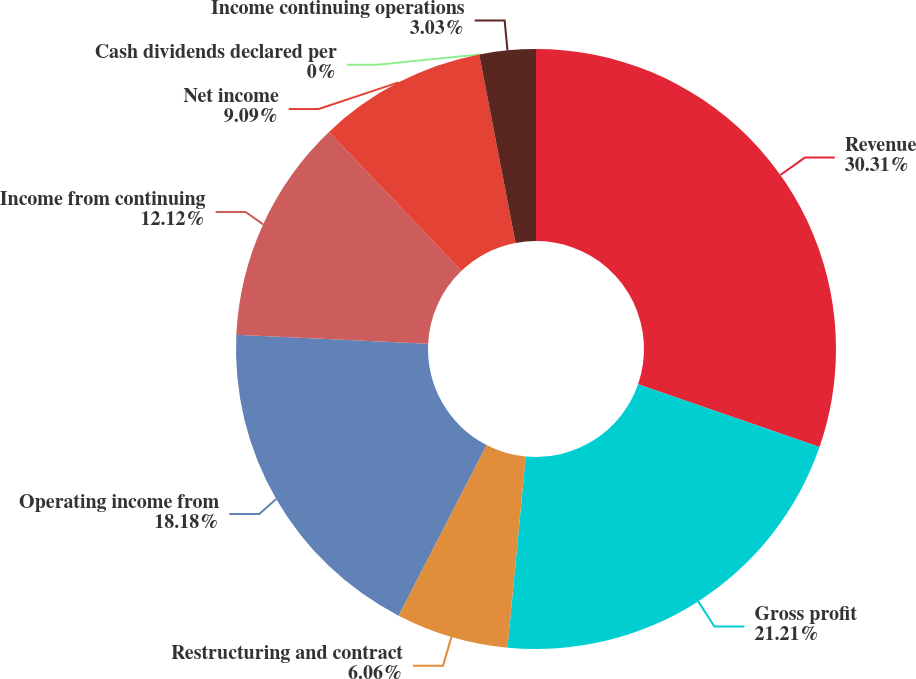Convert chart to OTSL. <chart><loc_0><loc_0><loc_500><loc_500><pie_chart><fcel>Revenue<fcel>Gross profit<fcel>Restructuring and contract<fcel>Operating income from<fcel>Income from continuing<fcel>Net income<fcel>Cash dividends declared per<fcel>Income continuing operations<nl><fcel>30.3%<fcel>21.21%<fcel>6.06%<fcel>18.18%<fcel>12.12%<fcel>9.09%<fcel>0.0%<fcel>3.03%<nl></chart> 